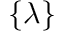<formula> <loc_0><loc_0><loc_500><loc_500>\{ \lambda \}</formula> 